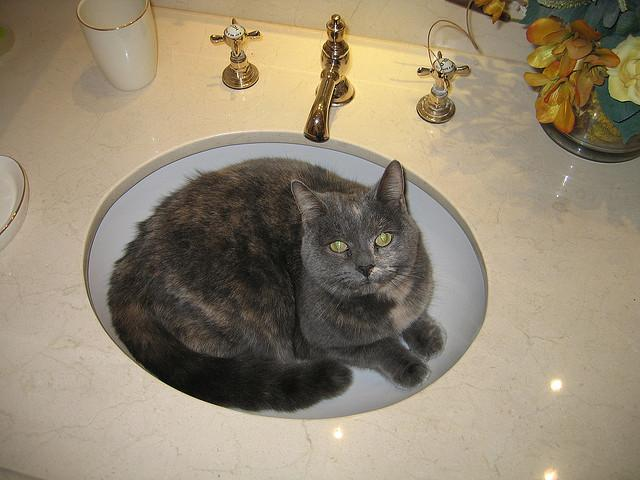Why should this cat be scared?

Choices:
A) water
B) fire
C) noise
D) physical harm water 